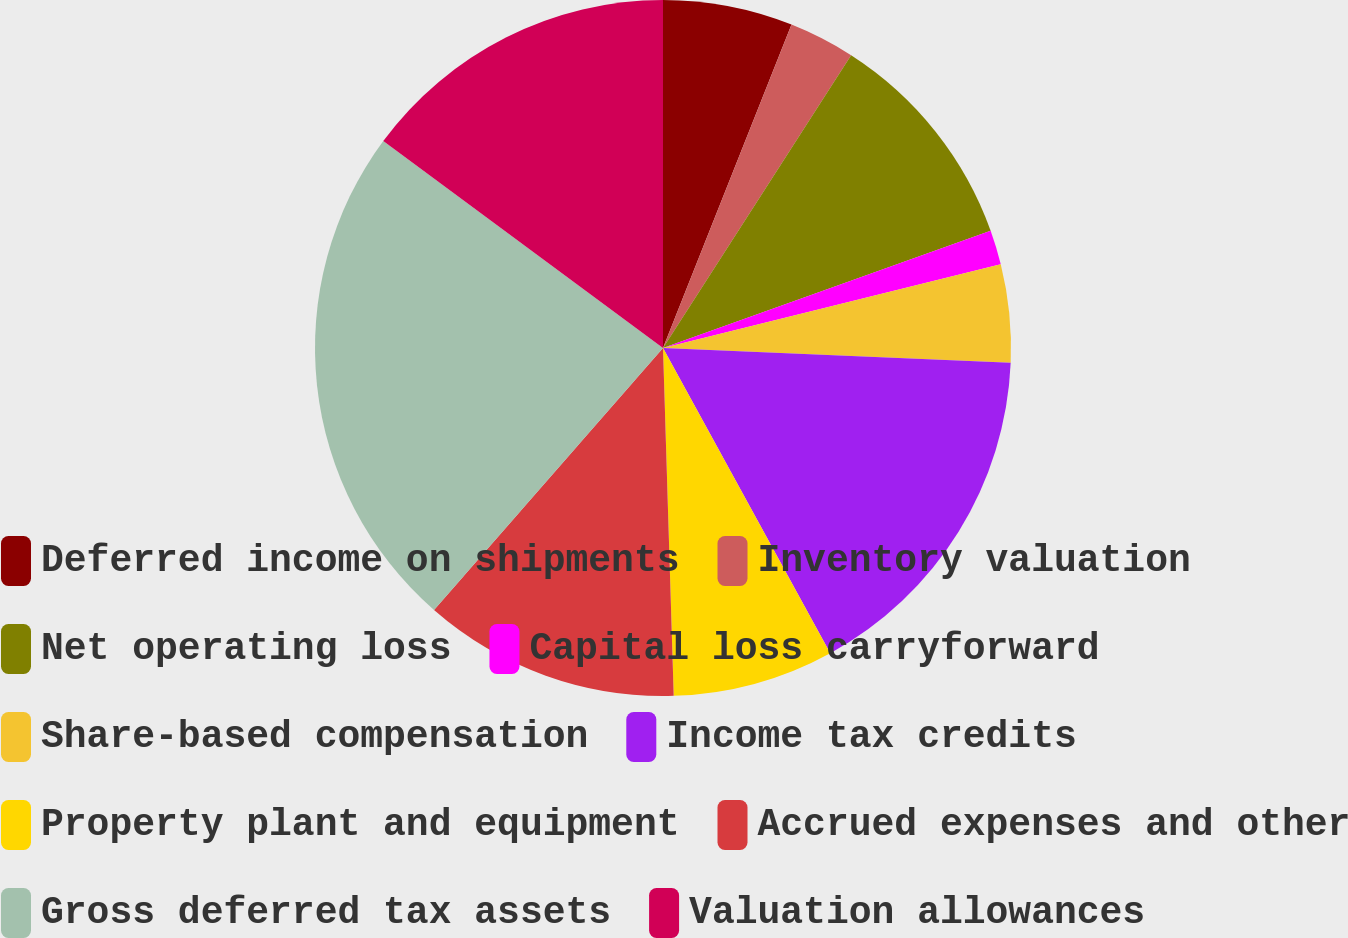Convert chart. <chart><loc_0><loc_0><loc_500><loc_500><pie_chart><fcel>Deferred income on shipments<fcel>Inventory valuation<fcel>Net operating loss<fcel>Capital loss carryforward<fcel>Share-based compensation<fcel>Income tax credits<fcel>Property plant and equipment<fcel>Accrued expenses and other<fcel>Gross deferred tax assets<fcel>Valuation allowances<nl><fcel>6.02%<fcel>3.07%<fcel>10.44%<fcel>1.6%<fcel>4.55%<fcel>16.34%<fcel>7.49%<fcel>11.92%<fcel>23.71%<fcel>14.86%<nl></chart> 